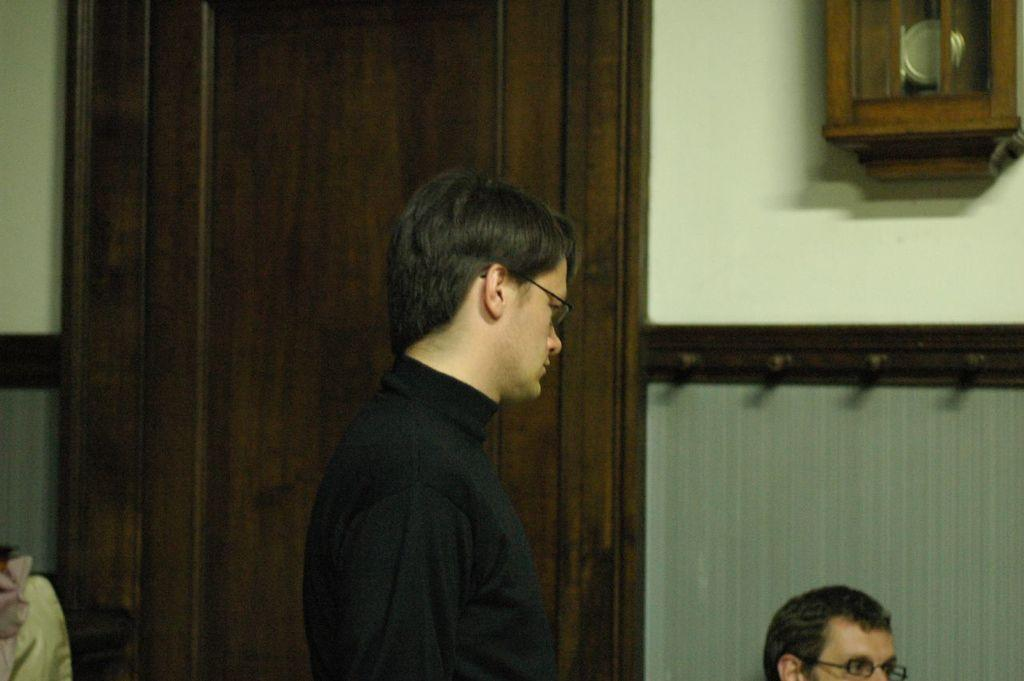What is the person in the black t-shirt doing in the image? The provided facts do not specify what the person in the black t-shirt is doing. Can you describe the other person in the image? The provided facts do not specify any details about the other person in the image. What object in the image can be used to tell time? There is a wall clock in the image that can be used to tell time. What architectural feature is present in the image? There is a door in the image. What is the committee's decision regarding the zinc content in the image? There is no mention of a committee or zinc content in the image. 